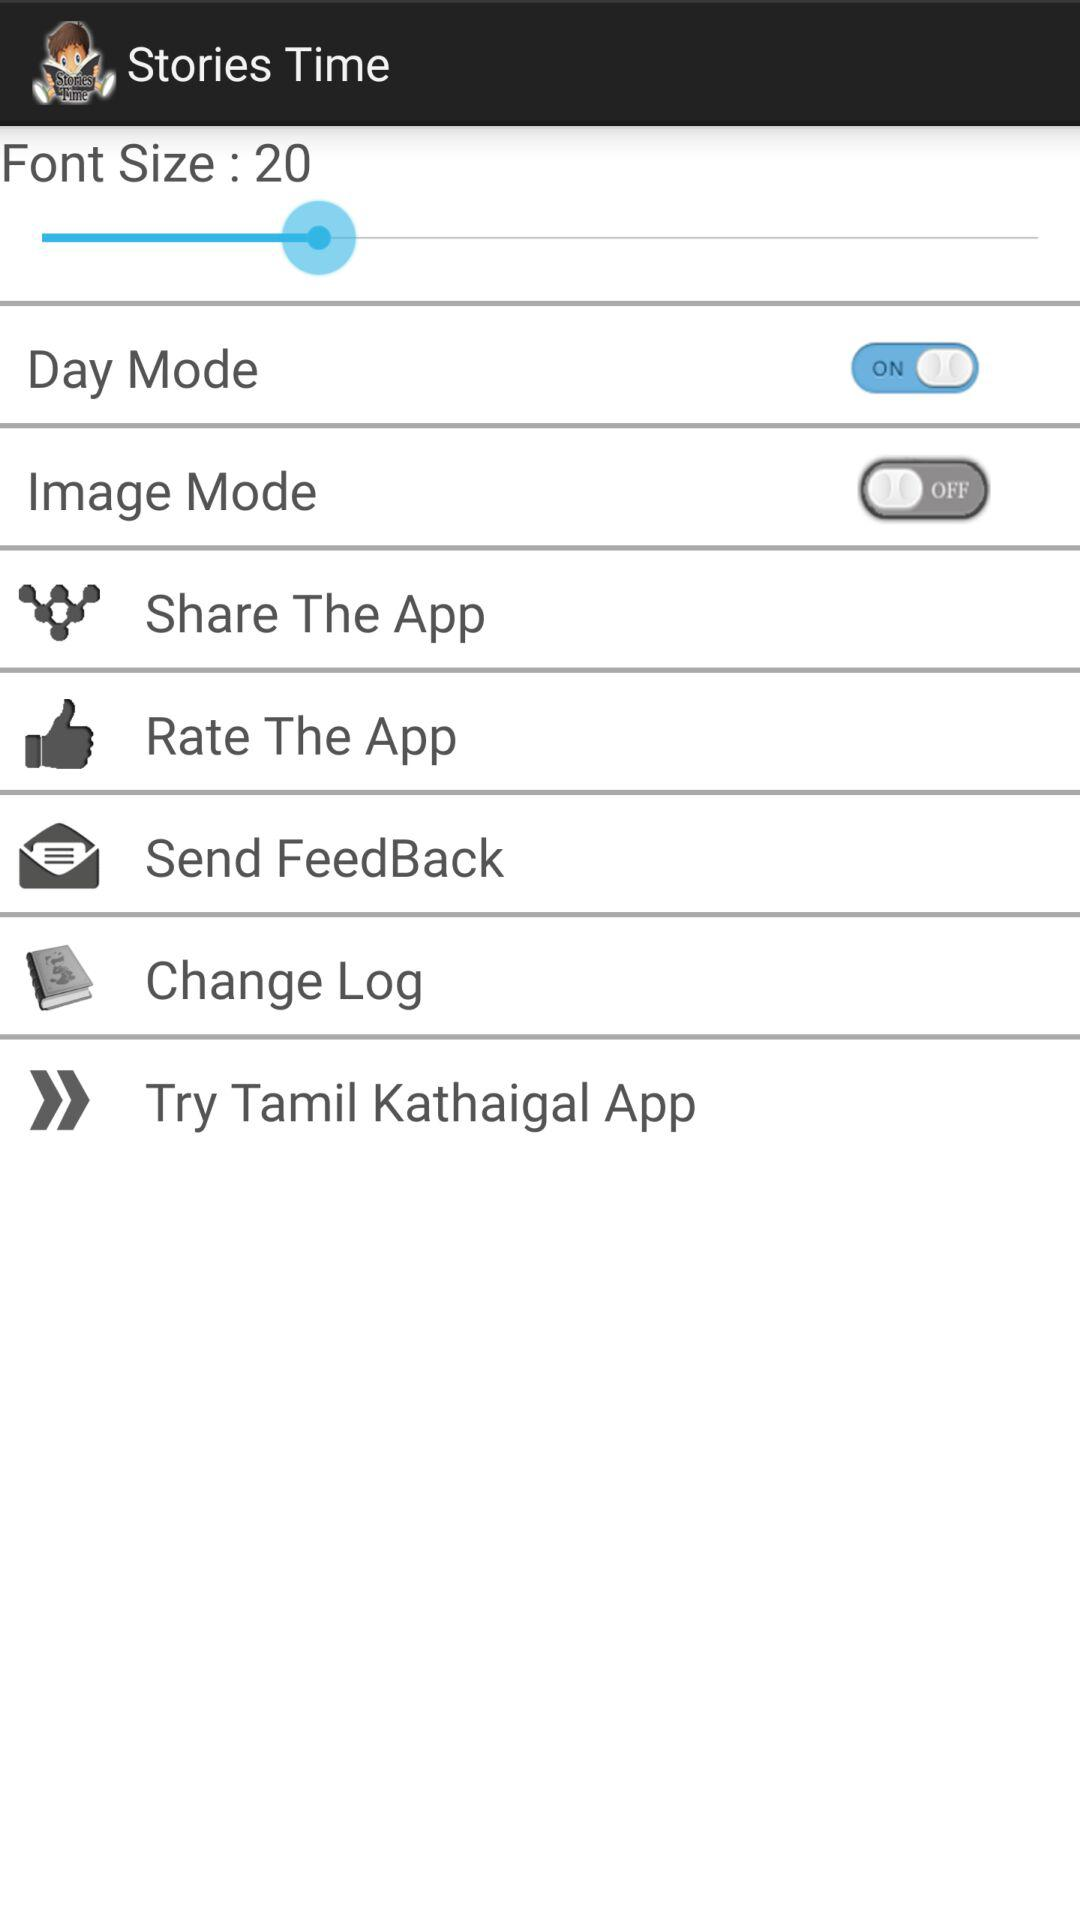What is the font size? The font size is 20. 